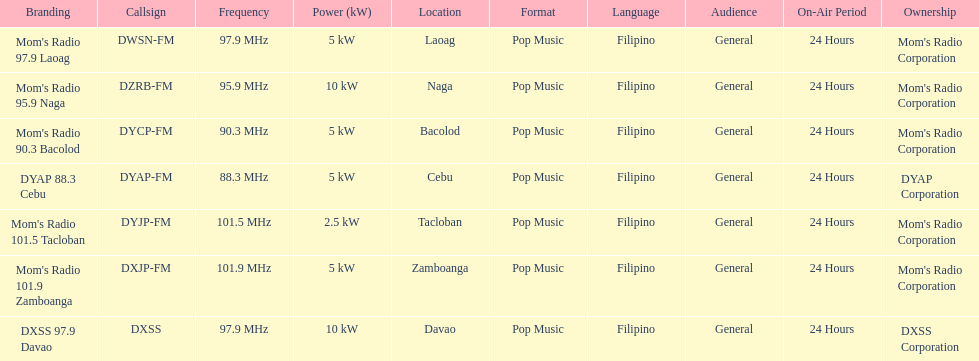What is the difference in kw between naga and bacolod radio? 5 kW. 